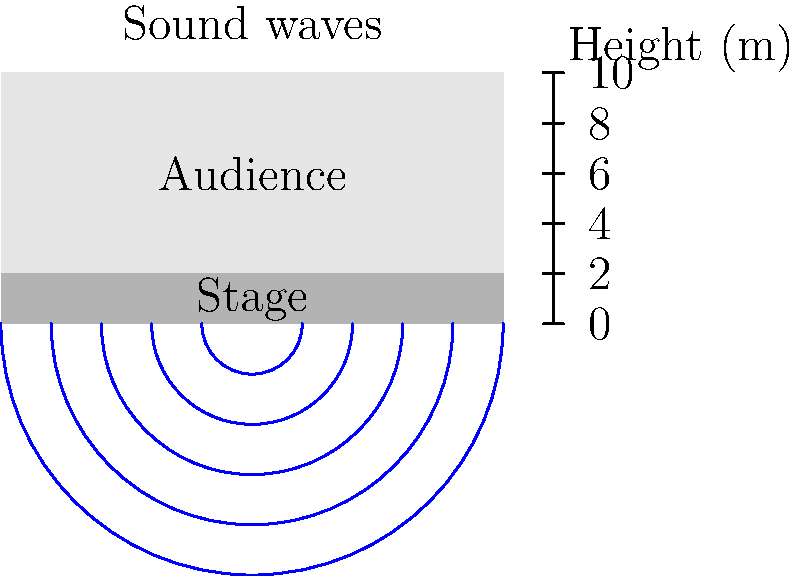In the auditorium shown above, a singer on stage produces a sound wave with a frequency of 440 Hz. If the speed of sound in air is 343 m/s, what is the wavelength of this sound wave? (Assume the temperature and air conditions in the auditorium are constant.) To find the wavelength of the sound wave, we can use the wave equation that relates wave speed, frequency, and wavelength. Here's how we solve it step-by-step:

1. Recall the wave equation: $v = f \lambda$
   Where:
   $v$ is the wave speed (in m/s)
   $f$ is the frequency (in Hz)
   $\lambda$ is the wavelength (in m)

2. We are given:
   - Speed of sound, $v = 343$ m/s
   - Frequency, $f = 440$ Hz

3. Rearrange the equation to solve for wavelength:
   $\lambda = \frac{v}{f}$

4. Substitute the known values:
   $\lambda = \frac{343 \text{ m/s}}{440 \text{ Hz}}$

5. Calculate:
   $\lambda = 0.78$ m

Therefore, the wavelength of the 440 Hz sound wave in the auditorium is 0.78 meters.
Answer: 0.78 m 